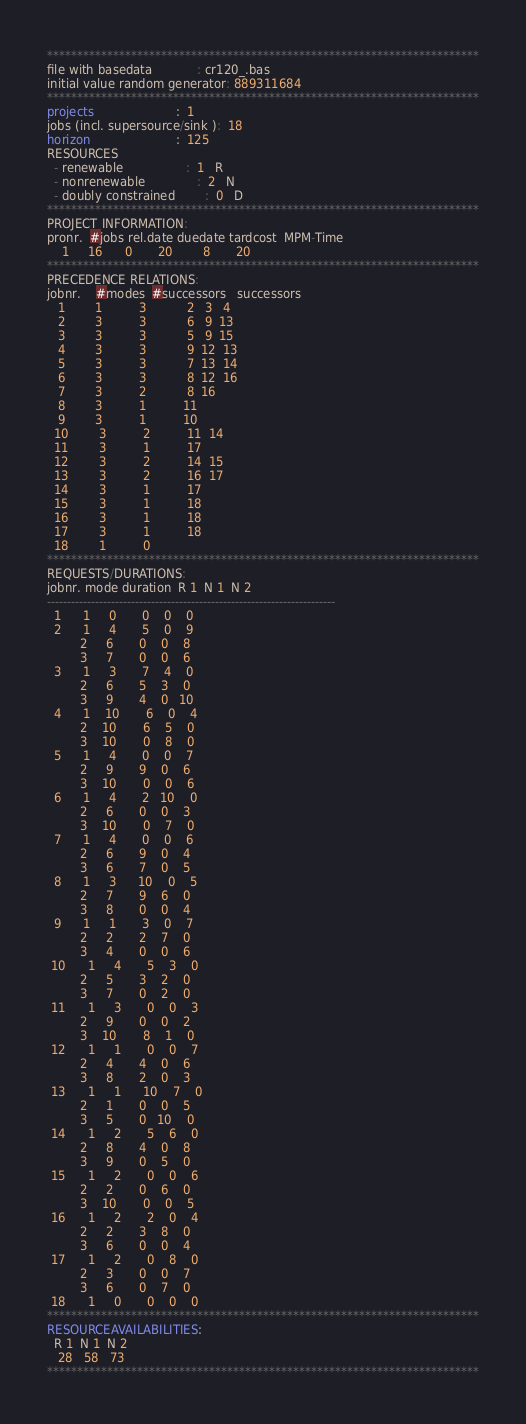<code> <loc_0><loc_0><loc_500><loc_500><_ObjectiveC_>************************************************************************
file with basedata            : cr120_.bas
initial value random generator: 889311684
************************************************************************
projects                      :  1
jobs (incl. supersource/sink ):  18
horizon                       :  125
RESOURCES
  - renewable                 :  1   R
  - nonrenewable              :  2   N
  - doubly constrained        :  0   D
************************************************************************
PROJECT INFORMATION:
pronr.  #jobs rel.date duedate tardcost  MPM-Time
    1     16      0       20        8       20
************************************************************************
PRECEDENCE RELATIONS:
jobnr.    #modes  #successors   successors
   1        1          3           2   3   4
   2        3          3           6   9  13
   3        3          3           5   9  15
   4        3          3           9  12  13
   5        3          3           7  13  14
   6        3          3           8  12  16
   7        3          2           8  16
   8        3          1          11
   9        3          1          10
  10        3          2          11  14
  11        3          1          17
  12        3          2          14  15
  13        3          2          16  17
  14        3          1          17
  15        3          1          18
  16        3          1          18
  17        3          1          18
  18        1          0        
************************************************************************
REQUESTS/DURATIONS:
jobnr. mode duration  R 1  N 1  N 2
------------------------------------------------------------------------
  1      1     0       0    0    0
  2      1     4       5    0    9
         2     6       0    0    8
         3     7       0    0    6
  3      1     3       7    4    0
         2     6       5    3    0
         3     9       4    0   10
  4      1    10       6    0    4
         2    10       6    5    0
         3    10       0    8    0
  5      1     4       0    0    7
         2     9       9    0    6
         3    10       0    0    6
  6      1     4       2   10    0
         2     6       0    0    3
         3    10       0    7    0
  7      1     4       0    0    6
         2     6       9    0    4
         3     6       7    0    5
  8      1     3      10    0    5
         2     7       9    6    0
         3     8       0    0    4
  9      1     1       3    0    7
         2     2       2    7    0
         3     4       0    0    6
 10      1     4       5    3    0
         2     5       3    2    0
         3     7       0    2    0
 11      1     3       0    0    3
         2     9       0    0    2
         3    10       8    1    0
 12      1     1       0    0    7
         2     4       4    0    6
         3     8       2    0    3
 13      1     1      10    7    0
         2     1       0    0    5
         3     5       0   10    0
 14      1     2       5    6    0
         2     8       4    0    8
         3     9       0    5    0
 15      1     2       0    0    6
         2     2       0    6    0
         3    10       0    0    5
 16      1     2       2    0    4
         2     2       3    8    0
         3     6       0    0    4
 17      1     2       0    8    0
         2     3       0    0    7
         3     6       0    7    0
 18      1     0       0    0    0
************************************************************************
RESOURCEAVAILABILITIES:
  R 1  N 1  N 2
   28   58   73
************************************************************************
</code> 